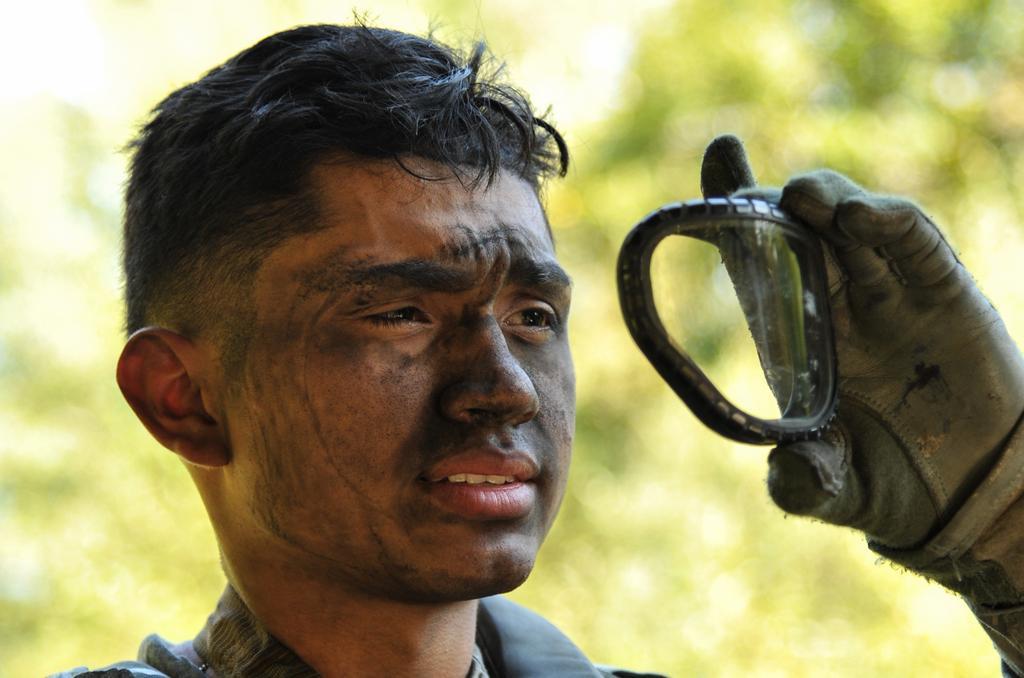Can you describe this image briefly? In this image we can see a man is standing, he is wearing the gloves and holding an object in the hand, at the back there are trees. 